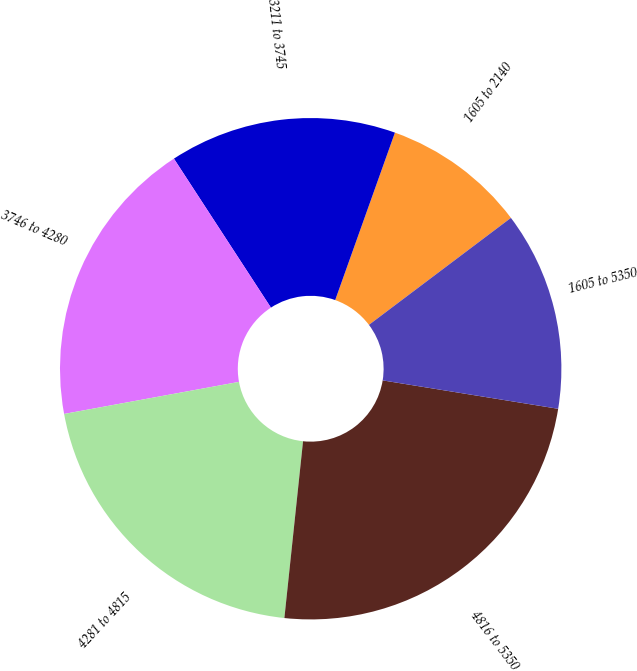Convert chart. <chart><loc_0><loc_0><loc_500><loc_500><pie_chart><fcel>1605 to 2140<fcel>3211 to 3745<fcel>3746 to 4280<fcel>4281 to 4815<fcel>4816 to 5350<fcel>1605 to 5350<nl><fcel>9.27%<fcel>14.64%<fcel>18.7%<fcel>20.44%<fcel>24.12%<fcel>12.83%<nl></chart> 